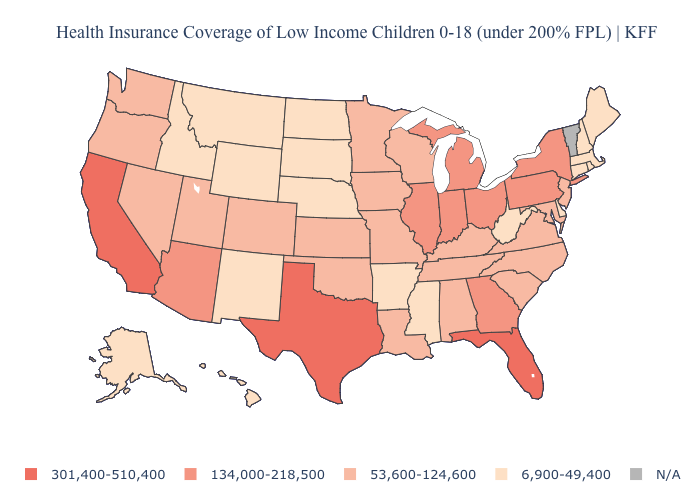Among the states that border Indiana , does Michigan have the highest value?
Answer briefly. Yes. What is the value of North Dakota?
Quick response, please. 6,900-49,400. What is the value of Maine?
Give a very brief answer. 6,900-49,400. Name the states that have a value in the range 53,600-124,600?
Quick response, please. Alabama, Colorado, Iowa, Kansas, Kentucky, Louisiana, Maryland, Minnesota, Missouri, Nevada, New Jersey, North Carolina, Oklahoma, Oregon, South Carolina, Tennessee, Utah, Virginia, Washington, Wisconsin. What is the value of Illinois?
Quick response, please. 134,000-218,500. What is the lowest value in the USA?
Write a very short answer. 6,900-49,400. What is the value of Wisconsin?
Answer briefly. 53,600-124,600. What is the value of Maine?
Quick response, please. 6,900-49,400. What is the highest value in states that border Georgia?
Answer briefly. 301,400-510,400. Among the states that border Connecticut , does Massachusetts have the highest value?
Short answer required. No. Does Maine have the lowest value in the USA?
Give a very brief answer. Yes. What is the highest value in the USA?
Keep it brief. 301,400-510,400. What is the value of Minnesota?
Write a very short answer. 53,600-124,600. Among the states that border Colorado , which have the lowest value?
Keep it brief. Nebraska, New Mexico, Wyoming. 